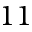Convert formula to latex. <formula><loc_0><loc_0><loc_500><loc_500>1 1</formula> 